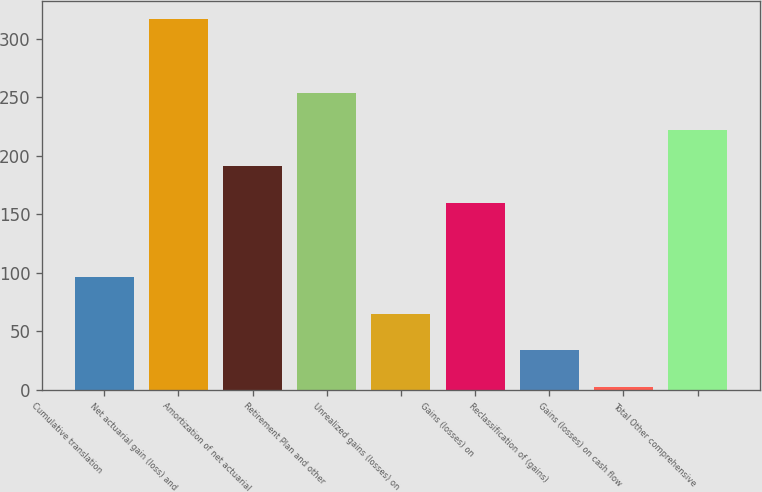<chart> <loc_0><loc_0><loc_500><loc_500><bar_chart><fcel>Cumulative translation<fcel>Net actuarial gain (loss) and<fcel>Amortization of net actuarial<fcel>Retirement Plan and other<fcel>Unrealized gains (losses) on<fcel>Gains (losses) on<fcel>Reclassification of (gains)<fcel>Gains (losses) on cash flow<fcel>Total Other comprehensive<nl><fcel>96.5<fcel>317<fcel>191<fcel>254<fcel>65<fcel>159.5<fcel>33.5<fcel>2<fcel>222.5<nl></chart> 